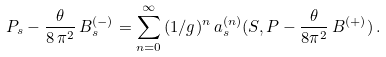Convert formula to latex. <formula><loc_0><loc_0><loc_500><loc_500>P _ { s } - \frac { \theta } { 8 \, \pi ^ { 2 } } \, B _ { s } ^ { ( - ) } = \sum _ { n = 0 } ^ { \infty } \, ( 1 / g ) ^ { n } \, a _ { s } ^ { ( n ) } ( S , P - \frac { \theta } { 8 \pi ^ { 2 } } \, B ^ { ( + ) } ) \, .</formula> 